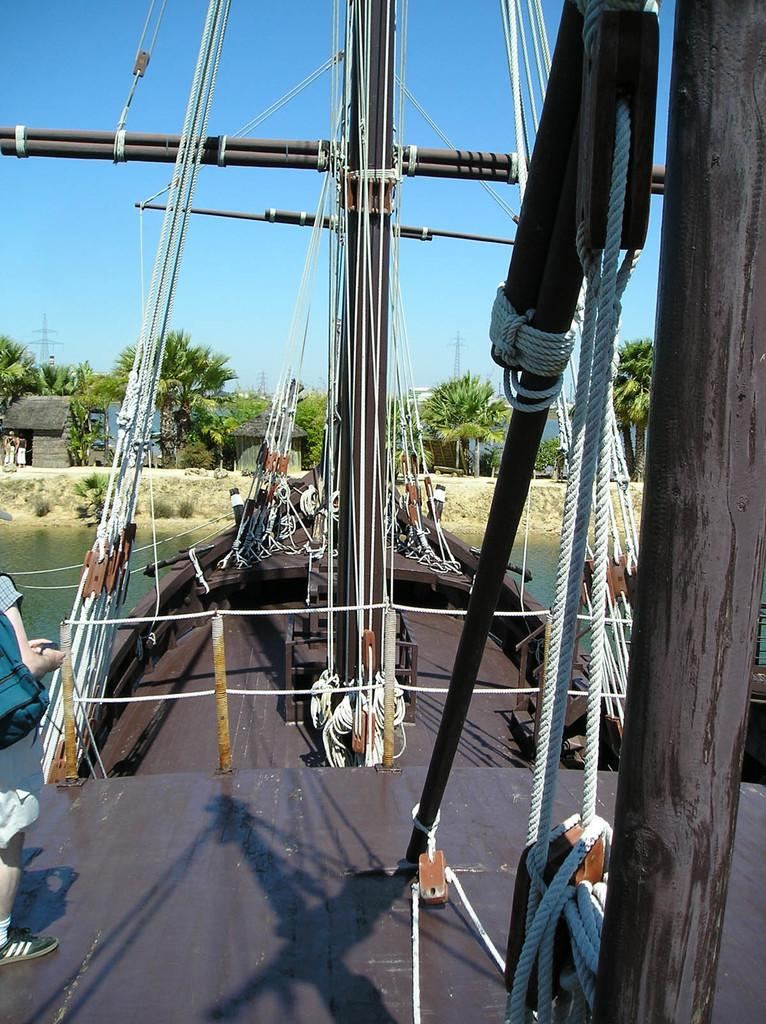What is the person in the image standing on? The person is standing on a ship in the image. What features can be seen on the ship? The ship has ropes, metal rods, and wooden poles. Where is the ship located? The ship is on water. What is visible in front of the ship? There are trees, houses, and electric poles in front of the ship. What type of downtown area can be seen in the image? There is no downtown area present in the image; it features a person standing on a ship with trees, houses, and electric poles in front of it. What color is the cap worn by the person on the ship? There is no cap visible on the person in the image. 